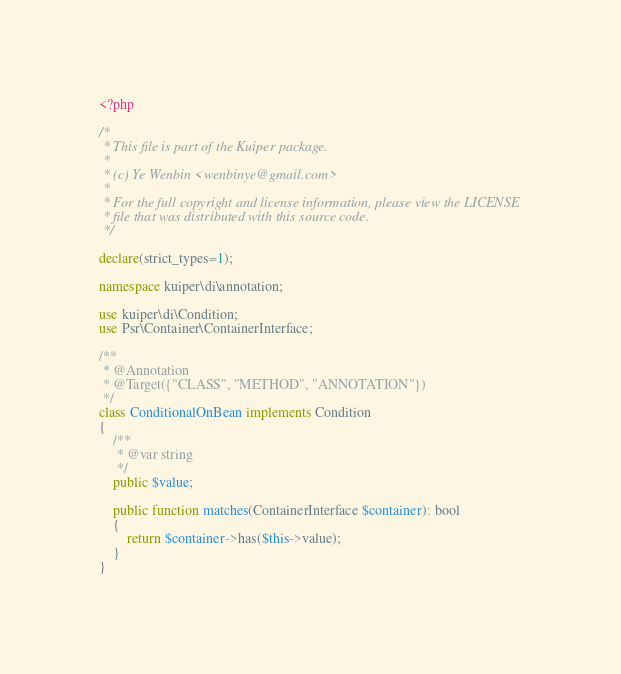Convert code to text. <code><loc_0><loc_0><loc_500><loc_500><_PHP_><?php

/*
 * This file is part of the Kuiper package.
 *
 * (c) Ye Wenbin <wenbinye@gmail.com>
 *
 * For the full copyright and license information, please view the LICENSE
 * file that was distributed with this source code.
 */

declare(strict_types=1);

namespace kuiper\di\annotation;

use kuiper\di\Condition;
use Psr\Container\ContainerInterface;

/**
 * @Annotation
 * @Target({"CLASS", "METHOD", "ANNOTATION"})
 */
class ConditionalOnBean implements Condition
{
    /**
     * @var string
     */
    public $value;

    public function matches(ContainerInterface $container): bool
    {
        return $container->has($this->value);
    }
}
</code> 